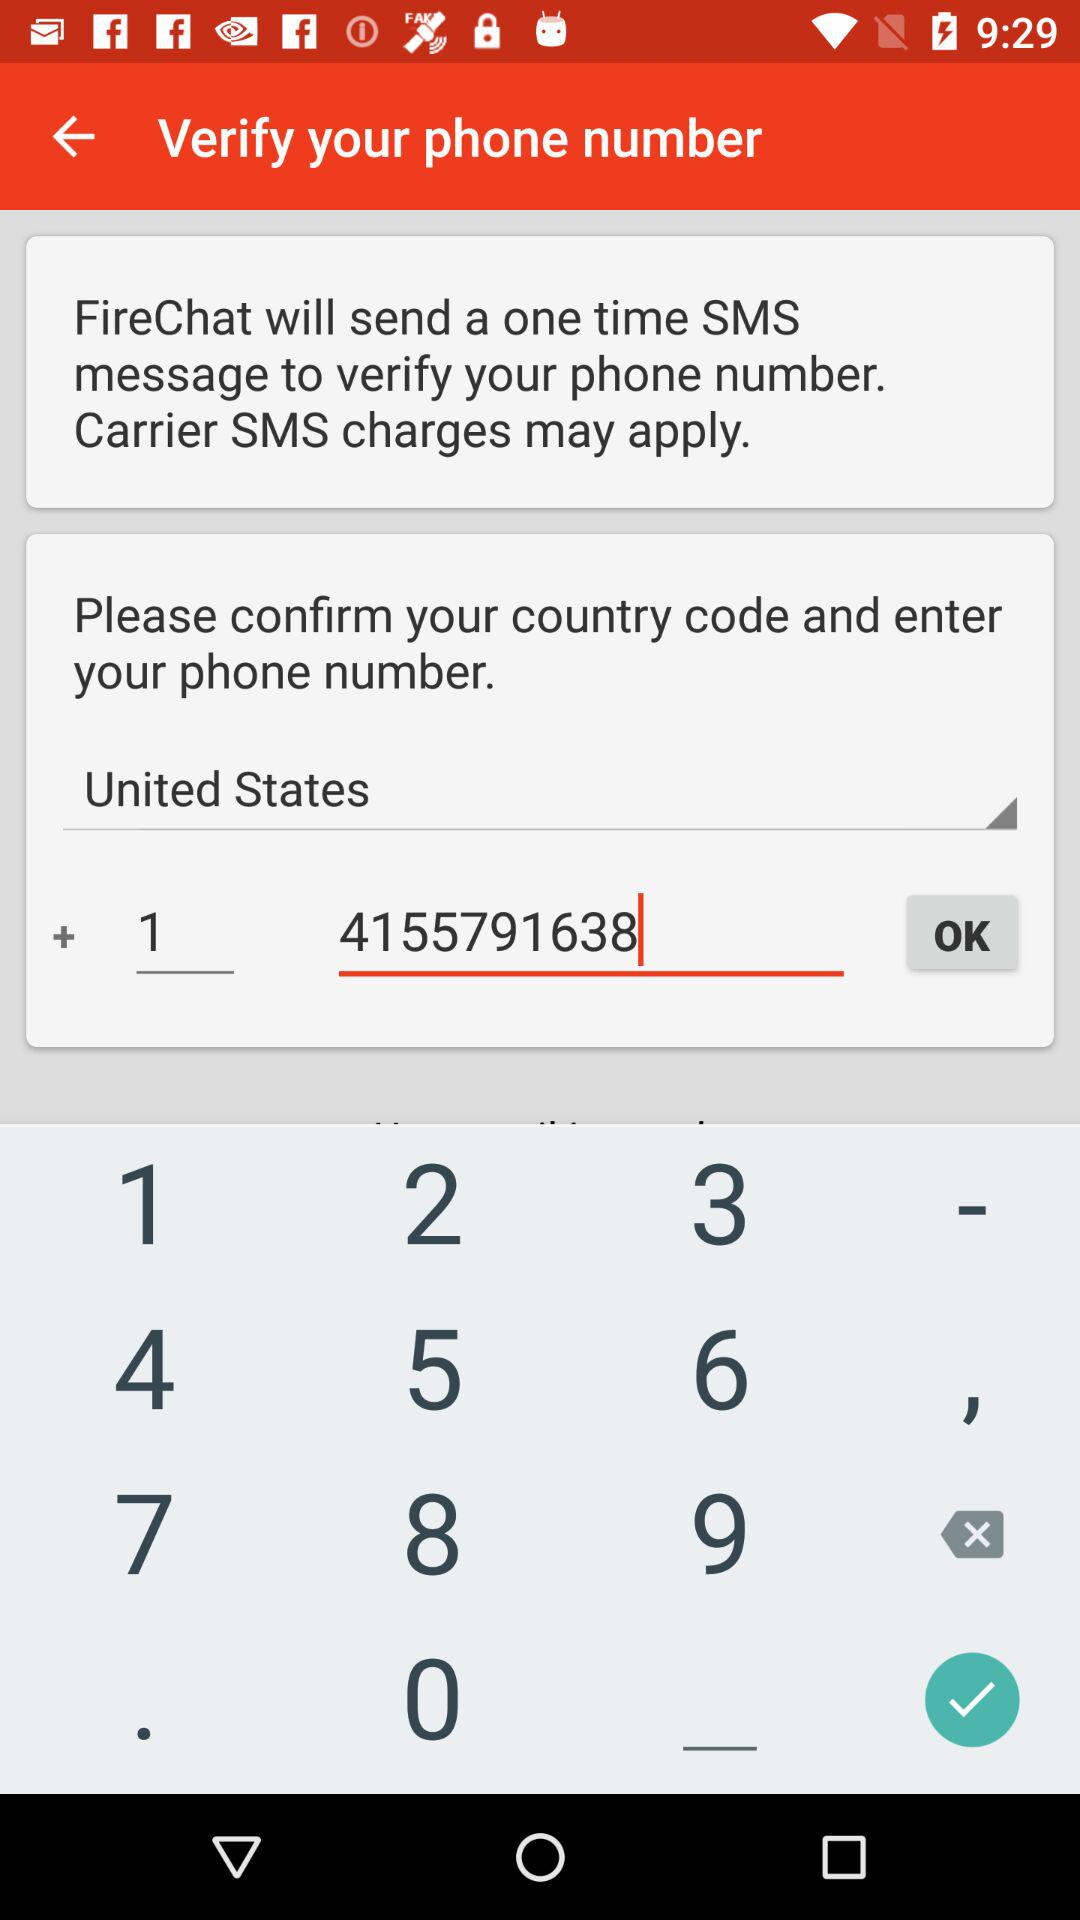What is the name of the application? The name of the application is "FireChat". 